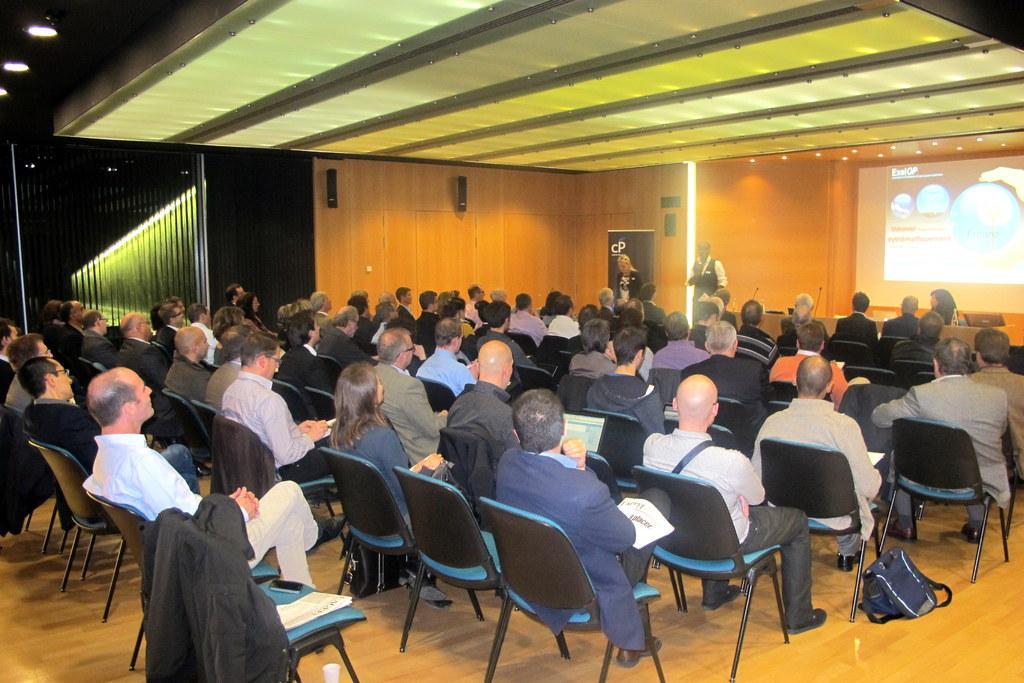Could you give a brief overview of what you see in this image? In this image I can see there are group of people who are sitting on a chair. On the right side of the image we have a projector screen. 